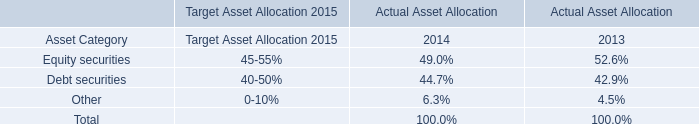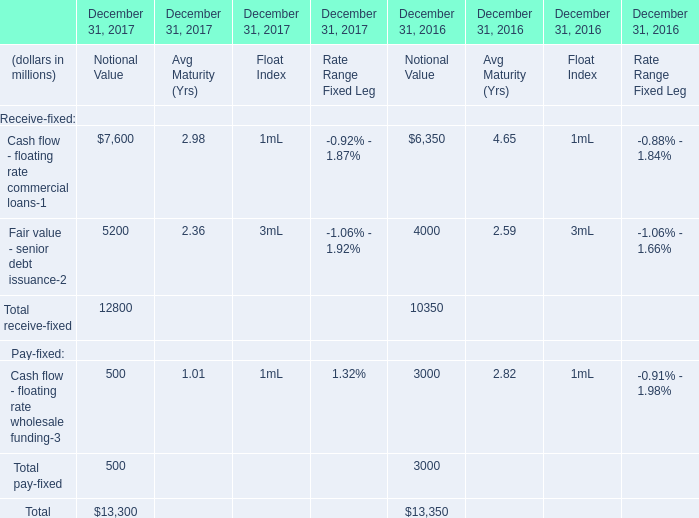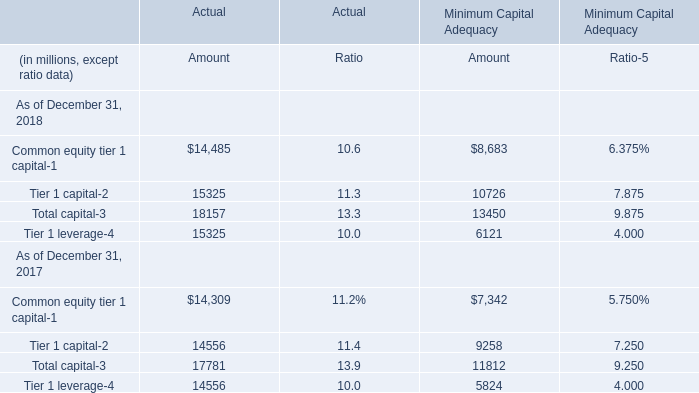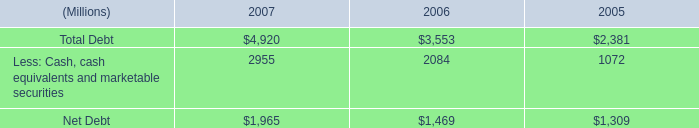what was the percentage change in the working capital from 2006 to 2007 
Computations: ((4.476 - 1.623) / 1.623)
Answer: 1.75786. 